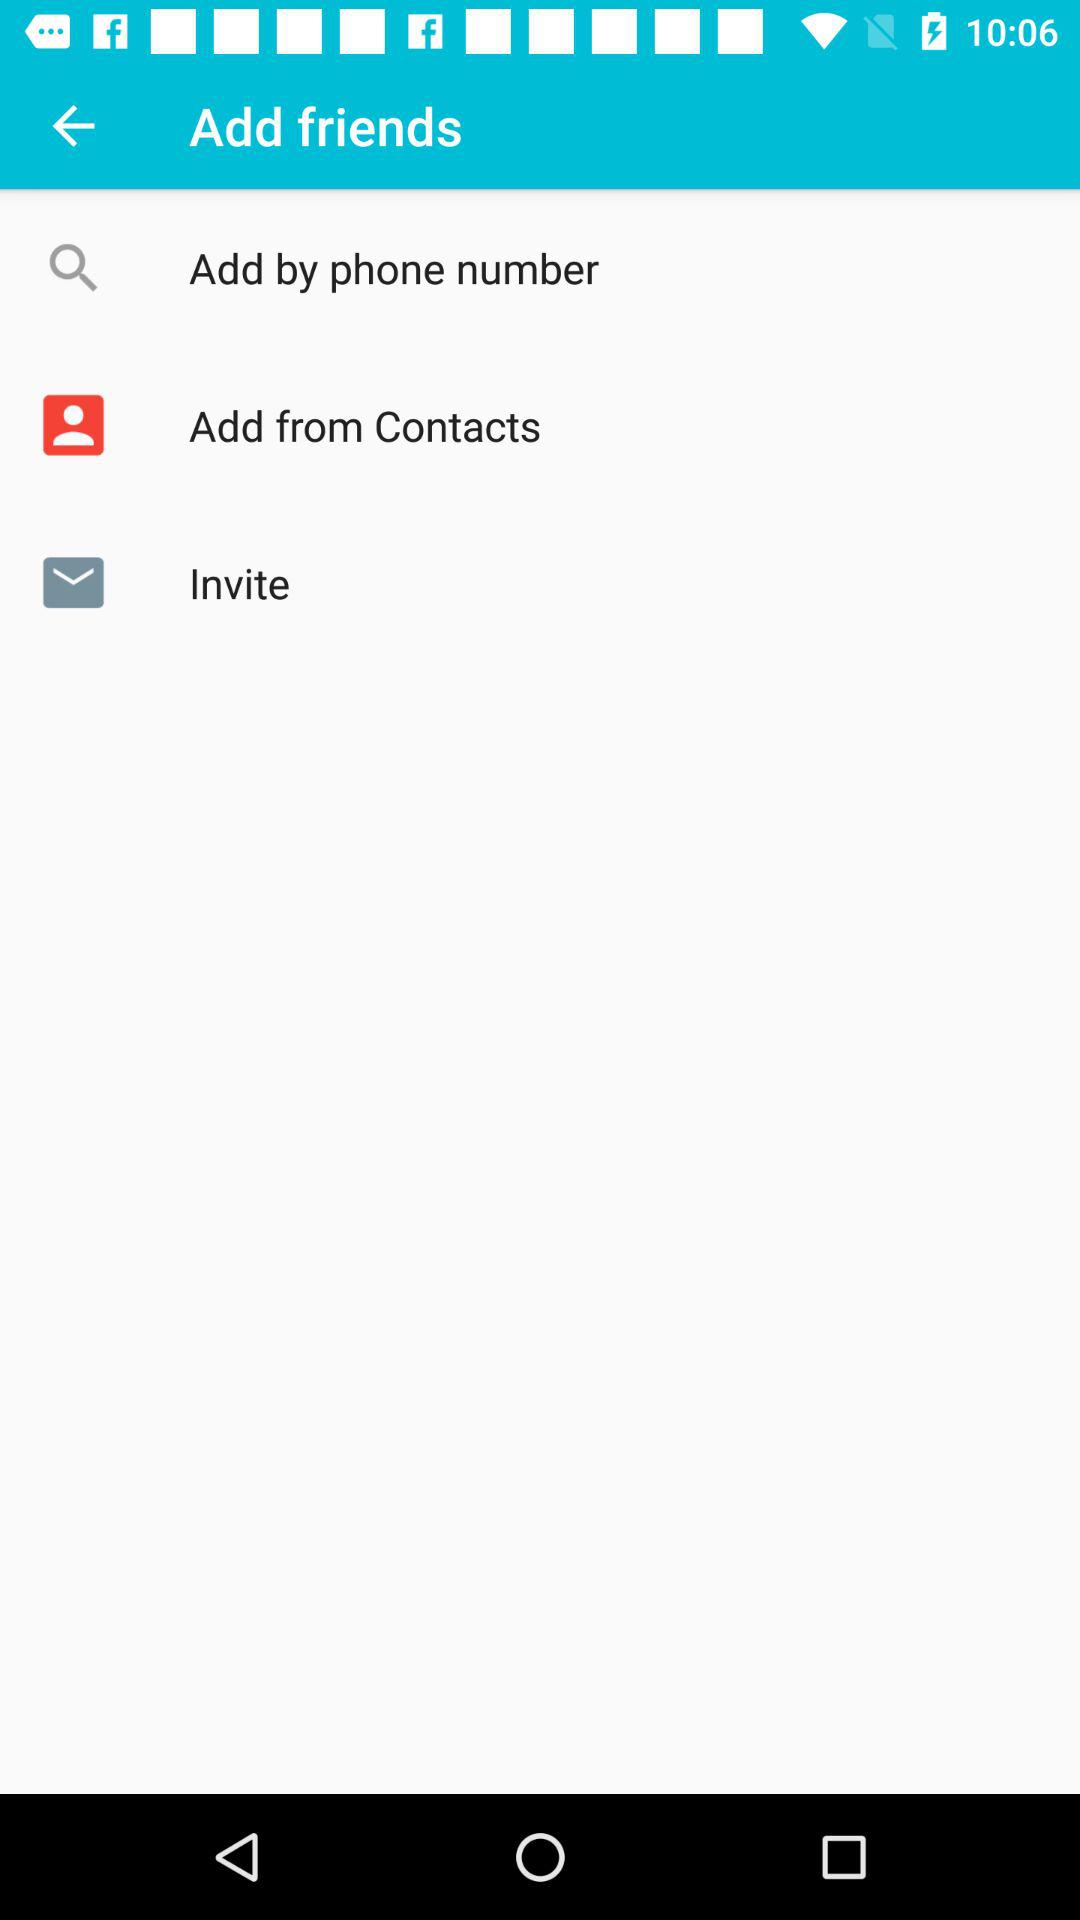How many options are there to add friends?
Answer the question using a single word or phrase. 3 